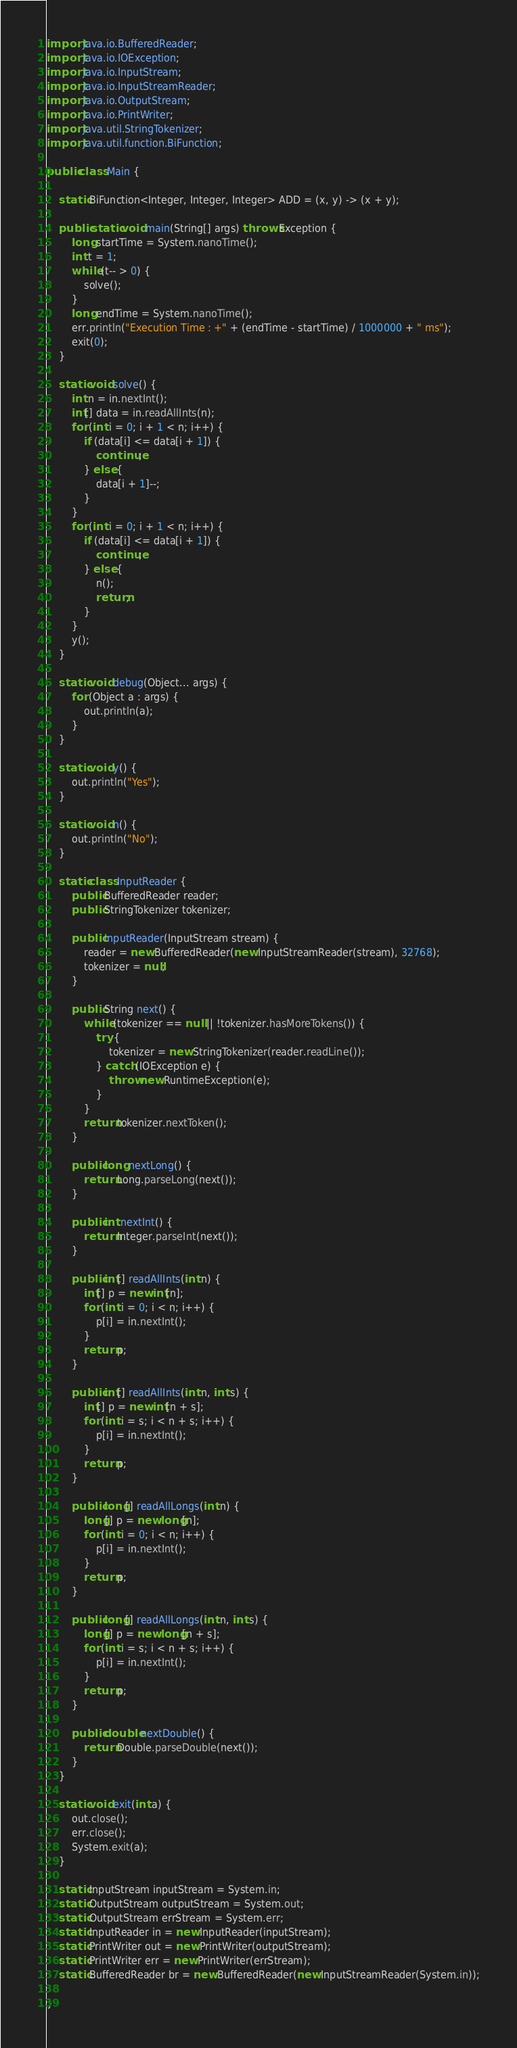Convert code to text. <code><loc_0><loc_0><loc_500><loc_500><_Java_>import java.io.BufferedReader;
import java.io.IOException;
import java.io.InputStream;
import java.io.InputStreamReader;
import java.io.OutputStream;
import java.io.PrintWriter;
import java.util.StringTokenizer;
import java.util.function.BiFunction;

public class Main {

    static BiFunction<Integer, Integer, Integer> ADD = (x, y) -> (x + y);

    public static void main(String[] args) throws Exception {
        long startTime = System.nanoTime();
        int t = 1;
        while (t-- > 0) {
            solve();
        }
        long endTime = System.nanoTime();
        err.println("Execution Time : +" + (endTime - startTime) / 1000000 + " ms");
        exit(0);
    }

    static void solve() {
        int n = in.nextInt();
        int[] data = in.readAllInts(n);
        for (int i = 0; i + 1 < n; i++) {
            if (data[i] <= data[i + 1]) {
                continue;
            } else {
                data[i + 1]--;
            }
        }
        for (int i = 0; i + 1 < n; i++) {
            if (data[i] <= data[i + 1]) {
                continue;
            } else {
                n();
                return;
            }
        }
        y();
    }

    static void debug(Object... args) {
        for (Object a : args) {
            out.println(a);
        }
    }

    static void y() {
        out.println("Yes");
    }

    static void n() {
        out.println("No");
    }

    static class InputReader {
        public BufferedReader reader;
        public StringTokenizer tokenizer;

        public InputReader(InputStream stream) {
            reader = new BufferedReader(new InputStreamReader(stream), 32768);
            tokenizer = null;
        }

        public String next() {
            while (tokenizer == null || !tokenizer.hasMoreTokens()) {
                try {
                    tokenizer = new StringTokenizer(reader.readLine());
                } catch (IOException e) {
                    throw new RuntimeException(e);
                }
            }
            return tokenizer.nextToken();
        }

        public long nextLong() {
            return Long.parseLong(next());
        }

        public int nextInt() {
            return Integer.parseInt(next());
        }

        public int[] readAllInts(int n) {
            int[] p = new int[n];
            for (int i = 0; i < n; i++) {
                p[i] = in.nextInt();
            }
            return p;
        }

        public int[] readAllInts(int n, int s) {
            int[] p = new int[n + s];
            for (int i = s; i < n + s; i++) {
                p[i] = in.nextInt();
            }
            return p;
        }

        public long[] readAllLongs(int n) {
            long[] p = new long[n];
            for (int i = 0; i < n; i++) {
                p[i] = in.nextInt();
            }
            return p;
        }

        public long[] readAllLongs(int n, int s) {
            long[] p = new long[n + s];
            for (int i = s; i < n + s; i++) {
                p[i] = in.nextInt();
            }
            return p;
        }

        public double nextDouble() {
            return Double.parseDouble(next());
        }
    }

    static void exit(int a) {
        out.close();
        err.close();
        System.exit(a);
    }

    static InputStream inputStream = System.in;
    static OutputStream outputStream = System.out;
    static OutputStream errStream = System.err;
    static InputReader in = new InputReader(inputStream);
    static PrintWriter out = new PrintWriter(outputStream);
    static PrintWriter err = new PrintWriter(errStream);
    static BufferedReader br = new BufferedReader(new InputStreamReader(System.in));

}
</code> 